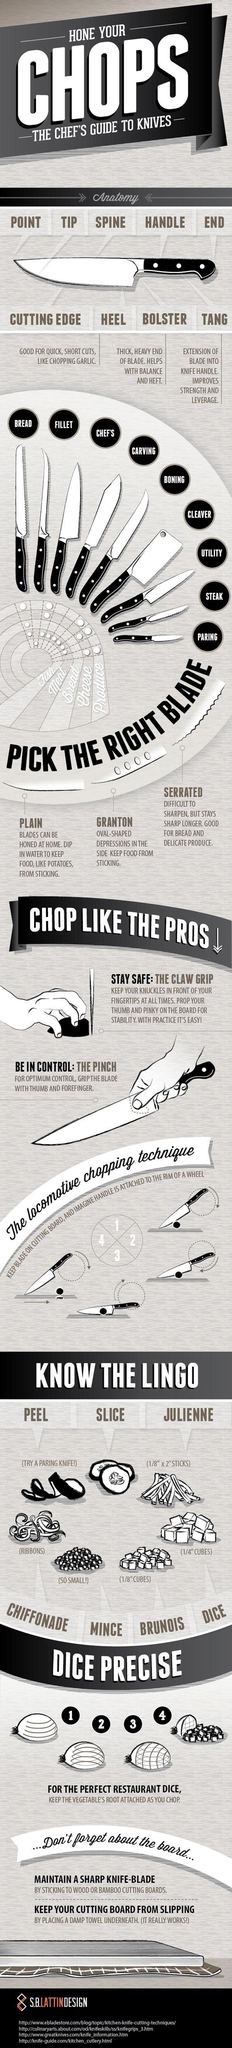What is the term for 1/8" cubes?
Answer the question with a short phrase. BRUNOIS Which blade prevents food from sticking to it? GRANTON 